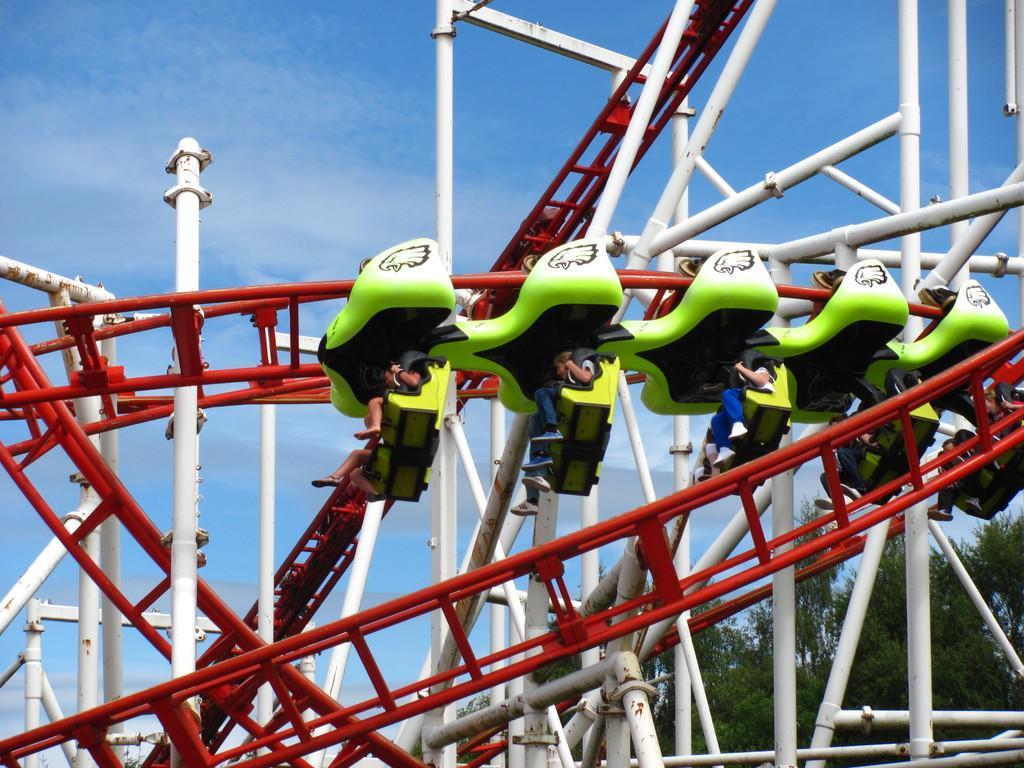Describe this image in one or two sentences. In this picture we can see a few people on a roll a coaster ride. There are some trees on the right side. Sky is blue in color. 